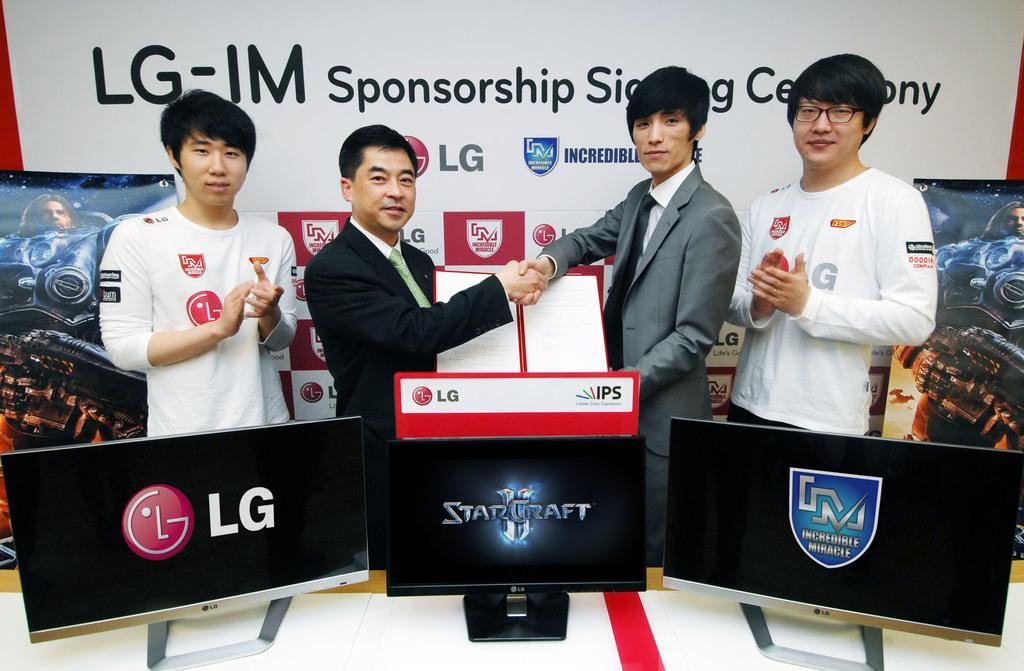Can you describe this image briefly? In this image we can see men standing on the floor and display screens are placed on the table in front of them. In the background there is an advertisement board. 